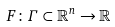Convert formula to latex. <formula><loc_0><loc_0><loc_500><loc_500>F \colon \Gamma \subset \mathbb { R } ^ { n } \rightarrow \mathbb { R }</formula> 